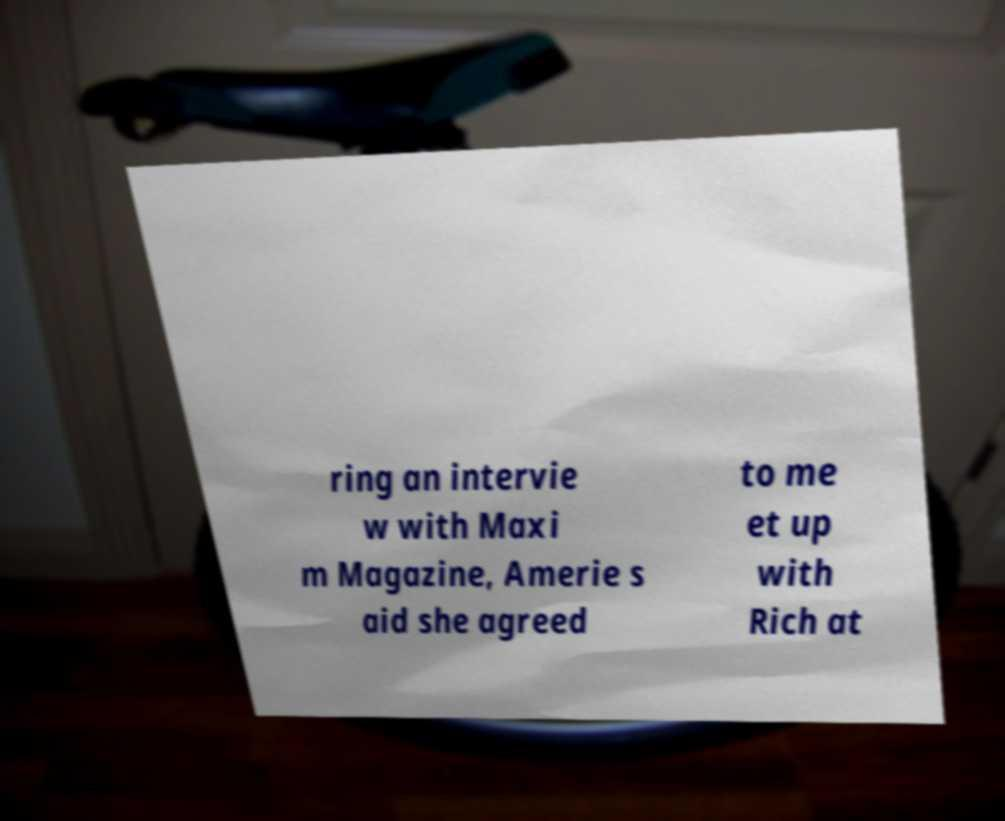What messages or text are displayed in this image? I need them in a readable, typed format. ring an intervie w with Maxi m Magazine, Amerie s aid she agreed to me et up with Rich at 